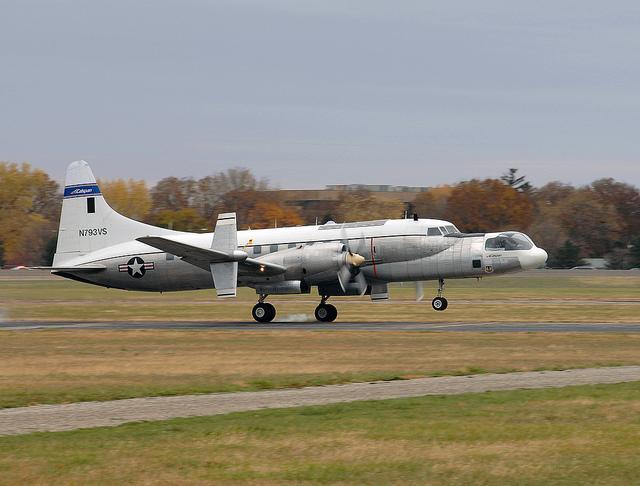How many donuts are pictured?
Give a very brief answer. 0. 